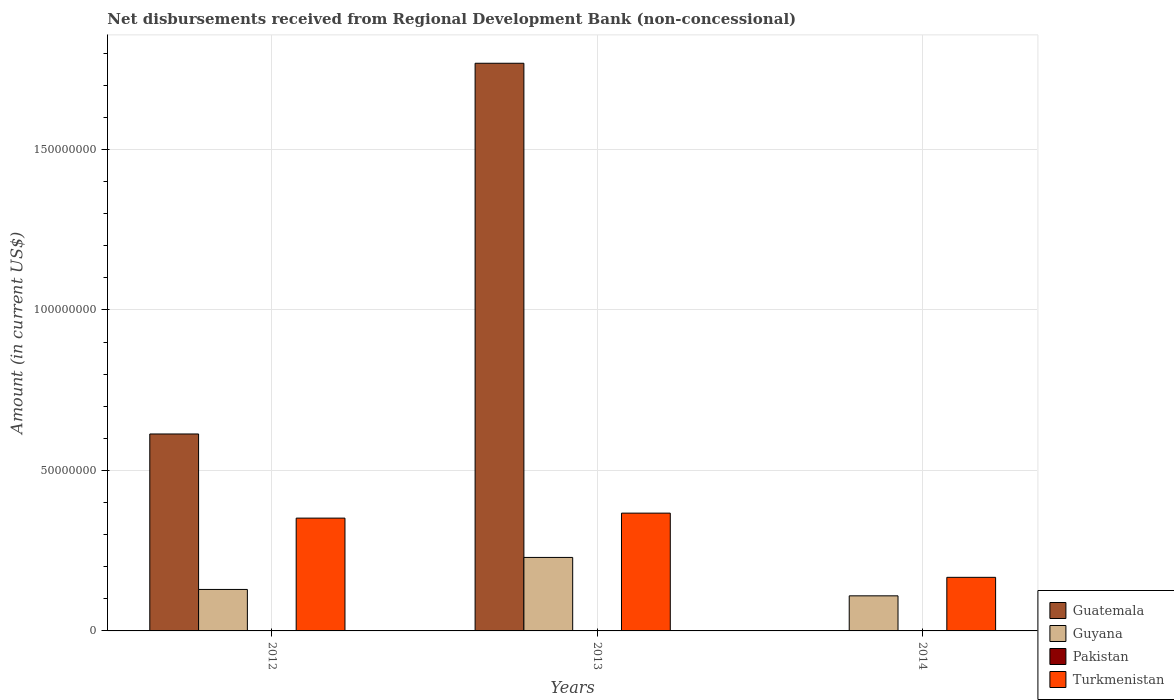How many groups of bars are there?
Provide a short and direct response. 3. Are the number of bars per tick equal to the number of legend labels?
Keep it short and to the point. No. Are the number of bars on each tick of the X-axis equal?
Offer a very short reply. No. In how many cases, is the number of bars for a given year not equal to the number of legend labels?
Your response must be concise. 3. What is the amount of disbursements received from Regional Development Bank in Pakistan in 2014?
Offer a terse response. 0. Across all years, what is the maximum amount of disbursements received from Regional Development Bank in Turkmenistan?
Make the answer very short. 3.67e+07. Across all years, what is the minimum amount of disbursements received from Regional Development Bank in Guatemala?
Provide a short and direct response. 0. What is the total amount of disbursements received from Regional Development Bank in Guyana in the graph?
Offer a very short reply. 4.68e+07. What is the difference between the amount of disbursements received from Regional Development Bank in Turkmenistan in 2012 and that in 2014?
Offer a terse response. 1.85e+07. What is the difference between the amount of disbursements received from Regional Development Bank in Guyana in 2014 and the amount of disbursements received from Regional Development Bank in Guatemala in 2012?
Give a very brief answer. -5.04e+07. What is the average amount of disbursements received from Regional Development Bank in Pakistan per year?
Keep it short and to the point. 0. In the year 2014, what is the difference between the amount of disbursements received from Regional Development Bank in Turkmenistan and amount of disbursements received from Regional Development Bank in Guyana?
Your answer should be very brief. 5.76e+06. In how many years, is the amount of disbursements received from Regional Development Bank in Guyana greater than 30000000 US$?
Your answer should be compact. 0. What is the ratio of the amount of disbursements received from Regional Development Bank in Guyana in 2012 to that in 2014?
Give a very brief answer. 1.18. Is the amount of disbursements received from Regional Development Bank in Guyana in 2012 less than that in 2013?
Make the answer very short. Yes. Is the difference between the amount of disbursements received from Regional Development Bank in Turkmenistan in 2013 and 2014 greater than the difference between the amount of disbursements received from Regional Development Bank in Guyana in 2013 and 2014?
Make the answer very short. Yes. What is the difference between the highest and the second highest amount of disbursements received from Regional Development Bank in Turkmenistan?
Ensure brevity in your answer.  1.55e+06. What is the difference between the highest and the lowest amount of disbursements received from Regional Development Bank in Guyana?
Your response must be concise. 1.20e+07. Is the sum of the amount of disbursements received from Regional Development Bank in Turkmenistan in 2012 and 2014 greater than the maximum amount of disbursements received from Regional Development Bank in Guatemala across all years?
Provide a succinct answer. No. Is it the case that in every year, the sum of the amount of disbursements received from Regional Development Bank in Guatemala and amount of disbursements received from Regional Development Bank in Turkmenistan is greater than the sum of amount of disbursements received from Regional Development Bank in Pakistan and amount of disbursements received from Regional Development Bank in Guyana?
Offer a terse response. No. How many bars are there?
Give a very brief answer. 8. Are all the bars in the graph horizontal?
Provide a succinct answer. No. What is the difference between two consecutive major ticks on the Y-axis?
Your response must be concise. 5.00e+07. Does the graph contain grids?
Provide a succinct answer. Yes. How many legend labels are there?
Ensure brevity in your answer.  4. What is the title of the graph?
Provide a succinct answer. Net disbursements received from Regional Development Bank (non-concessional). What is the Amount (in current US$) of Guatemala in 2012?
Give a very brief answer. 6.14e+07. What is the Amount (in current US$) in Guyana in 2012?
Offer a terse response. 1.29e+07. What is the Amount (in current US$) of Pakistan in 2012?
Your response must be concise. 0. What is the Amount (in current US$) of Turkmenistan in 2012?
Provide a short and direct response. 3.51e+07. What is the Amount (in current US$) of Guatemala in 2013?
Offer a very short reply. 1.77e+08. What is the Amount (in current US$) of Guyana in 2013?
Give a very brief answer. 2.29e+07. What is the Amount (in current US$) of Turkmenistan in 2013?
Your response must be concise. 3.67e+07. What is the Amount (in current US$) in Guatemala in 2014?
Offer a very short reply. 0. What is the Amount (in current US$) in Guyana in 2014?
Offer a terse response. 1.09e+07. What is the Amount (in current US$) of Turkmenistan in 2014?
Offer a terse response. 1.67e+07. Across all years, what is the maximum Amount (in current US$) in Guatemala?
Offer a terse response. 1.77e+08. Across all years, what is the maximum Amount (in current US$) of Guyana?
Give a very brief answer. 2.29e+07. Across all years, what is the maximum Amount (in current US$) of Turkmenistan?
Offer a very short reply. 3.67e+07. Across all years, what is the minimum Amount (in current US$) of Guatemala?
Give a very brief answer. 0. Across all years, what is the minimum Amount (in current US$) of Guyana?
Provide a short and direct response. 1.09e+07. Across all years, what is the minimum Amount (in current US$) of Turkmenistan?
Offer a very short reply. 1.67e+07. What is the total Amount (in current US$) in Guatemala in the graph?
Give a very brief answer. 2.38e+08. What is the total Amount (in current US$) in Guyana in the graph?
Give a very brief answer. 4.68e+07. What is the total Amount (in current US$) of Turkmenistan in the graph?
Provide a succinct answer. 8.85e+07. What is the difference between the Amount (in current US$) in Guatemala in 2012 and that in 2013?
Your answer should be very brief. -1.16e+08. What is the difference between the Amount (in current US$) in Guyana in 2012 and that in 2013?
Offer a very short reply. -9.97e+06. What is the difference between the Amount (in current US$) in Turkmenistan in 2012 and that in 2013?
Your answer should be compact. -1.55e+06. What is the difference between the Amount (in current US$) of Guyana in 2012 and that in 2014?
Ensure brevity in your answer.  1.99e+06. What is the difference between the Amount (in current US$) of Turkmenistan in 2012 and that in 2014?
Provide a succinct answer. 1.85e+07. What is the difference between the Amount (in current US$) of Guyana in 2013 and that in 2014?
Provide a succinct answer. 1.20e+07. What is the difference between the Amount (in current US$) in Turkmenistan in 2013 and that in 2014?
Your answer should be very brief. 2.00e+07. What is the difference between the Amount (in current US$) of Guatemala in 2012 and the Amount (in current US$) of Guyana in 2013?
Your response must be concise. 3.85e+07. What is the difference between the Amount (in current US$) in Guatemala in 2012 and the Amount (in current US$) in Turkmenistan in 2013?
Your response must be concise. 2.47e+07. What is the difference between the Amount (in current US$) of Guyana in 2012 and the Amount (in current US$) of Turkmenistan in 2013?
Ensure brevity in your answer.  -2.38e+07. What is the difference between the Amount (in current US$) of Guatemala in 2012 and the Amount (in current US$) of Guyana in 2014?
Your answer should be very brief. 5.04e+07. What is the difference between the Amount (in current US$) of Guatemala in 2012 and the Amount (in current US$) of Turkmenistan in 2014?
Keep it short and to the point. 4.47e+07. What is the difference between the Amount (in current US$) of Guyana in 2012 and the Amount (in current US$) of Turkmenistan in 2014?
Offer a terse response. -3.77e+06. What is the difference between the Amount (in current US$) of Guatemala in 2013 and the Amount (in current US$) of Guyana in 2014?
Keep it short and to the point. 1.66e+08. What is the difference between the Amount (in current US$) of Guatemala in 2013 and the Amount (in current US$) of Turkmenistan in 2014?
Give a very brief answer. 1.60e+08. What is the difference between the Amount (in current US$) of Guyana in 2013 and the Amount (in current US$) of Turkmenistan in 2014?
Your answer should be very brief. 6.20e+06. What is the average Amount (in current US$) in Guatemala per year?
Offer a very short reply. 7.94e+07. What is the average Amount (in current US$) in Guyana per year?
Offer a very short reply. 1.56e+07. What is the average Amount (in current US$) of Pakistan per year?
Offer a very short reply. 0. What is the average Amount (in current US$) in Turkmenistan per year?
Offer a terse response. 2.95e+07. In the year 2012, what is the difference between the Amount (in current US$) in Guatemala and Amount (in current US$) in Guyana?
Offer a terse response. 4.84e+07. In the year 2012, what is the difference between the Amount (in current US$) in Guatemala and Amount (in current US$) in Turkmenistan?
Your response must be concise. 2.62e+07. In the year 2012, what is the difference between the Amount (in current US$) of Guyana and Amount (in current US$) of Turkmenistan?
Make the answer very short. -2.22e+07. In the year 2013, what is the difference between the Amount (in current US$) of Guatemala and Amount (in current US$) of Guyana?
Offer a very short reply. 1.54e+08. In the year 2013, what is the difference between the Amount (in current US$) of Guatemala and Amount (in current US$) of Turkmenistan?
Keep it short and to the point. 1.40e+08. In the year 2013, what is the difference between the Amount (in current US$) in Guyana and Amount (in current US$) in Turkmenistan?
Offer a very short reply. -1.38e+07. In the year 2014, what is the difference between the Amount (in current US$) in Guyana and Amount (in current US$) in Turkmenistan?
Give a very brief answer. -5.76e+06. What is the ratio of the Amount (in current US$) of Guatemala in 2012 to that in 2013?
Your answer should be very brief. 0.35. What is the ratio of the Amount (in current US$) in Guyana in 2012 to that in 2013?
Offer a very short reply. 0.56. What is the ratio of the Amount (in current US$) in Turkmenistan in 2012 to that in 2013?
Your response must be concise. 0.96. What is the ratio of the Amount (in current US$) of Guyana in 2012 to that in 2014?
Keep it short and to the point. 1.18. What is the ratio of the Amount (in current US$) of Turkmenistan in 2012 to that in 2014?
Your answer should be compact. 2.11. What is the ratio of the Amount (in current US$) in Guyana in 2013 to that in 2014?
Ensure brevity in your answer.  2.09. What is the ratio of the Amount (in current US$) in Turkmenistan in 2013 to that in 2014?
Keep it short and to the point. 2.2. What is the difference between the highest and the second highest Amount (in current US$) of Guyana?
Make the answer very short. 9.97e+06. What is the difference between the highest and the second highest Amount (in current US$) of Turkmenistan?
Your answer should be very brief. 1.55e+06. What is the difference between the highest and the lowest Amount (in current US$) in Guatemala?
Make the answer very short. 1.77e+08. What is the difference between the highest and the lowest Amount (in current US$) of Guyana?
Give a very brief answer. 1.20e+07. What is the difference between the highest and the lowest Amount (in current US$) in Turkmenistan?
Provide a succinct answer. 2.00e+07. 